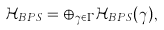<formula> <loc_0><loc_0><loc_500><loc_500>\mathcal { H } _ { B P S } = \oplus _ { \gamma \in \Gamma } \mathcal { H } _ { B P S } ( \gamma ) ,</formula> 